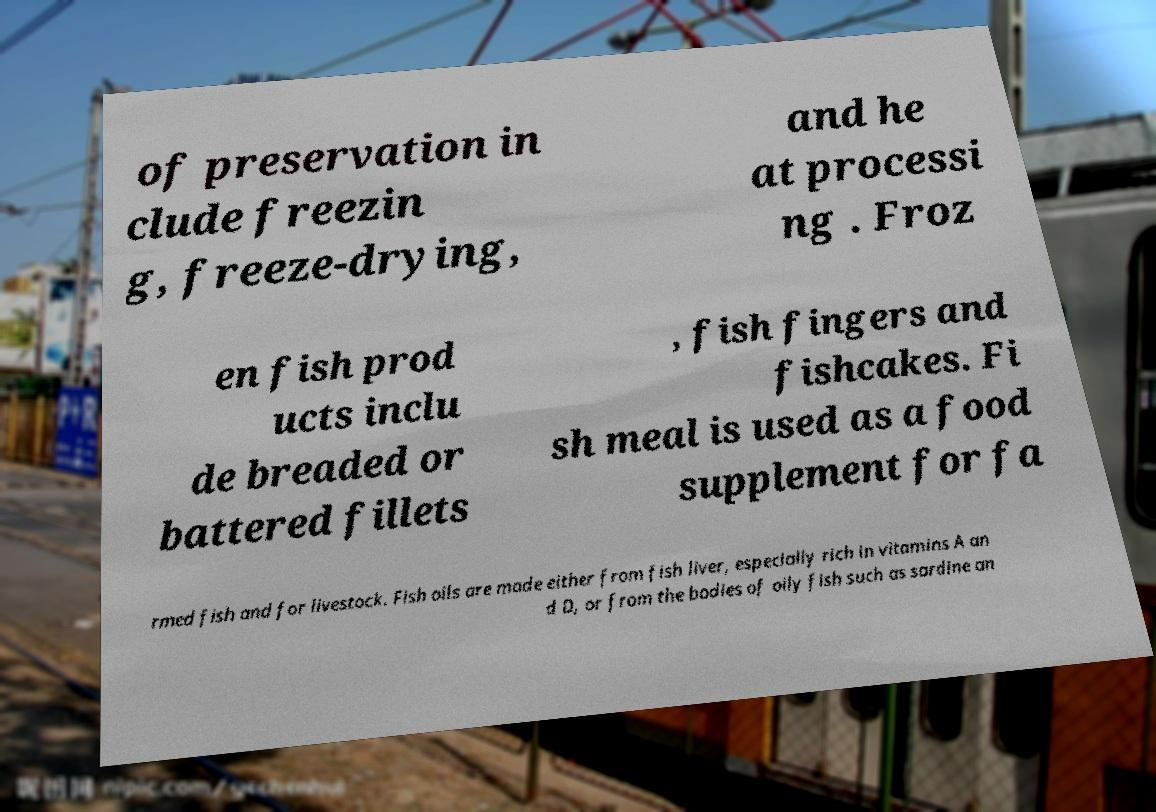Can you accurately transcribe the text from the provided image for me? of preservation in clude freezin g, freeze-drying, and he at processi ng . Froz en fish prod ucts inclu de breaded or battered fillets , fish fingers and fishcakes. Fi sh meal is used as a food supplement for fa rmed fish and for livestock. Fish oils are made either from fish liver, especially rich in vitamins A an d D, or from the bodies of oily fish such as sardine an 